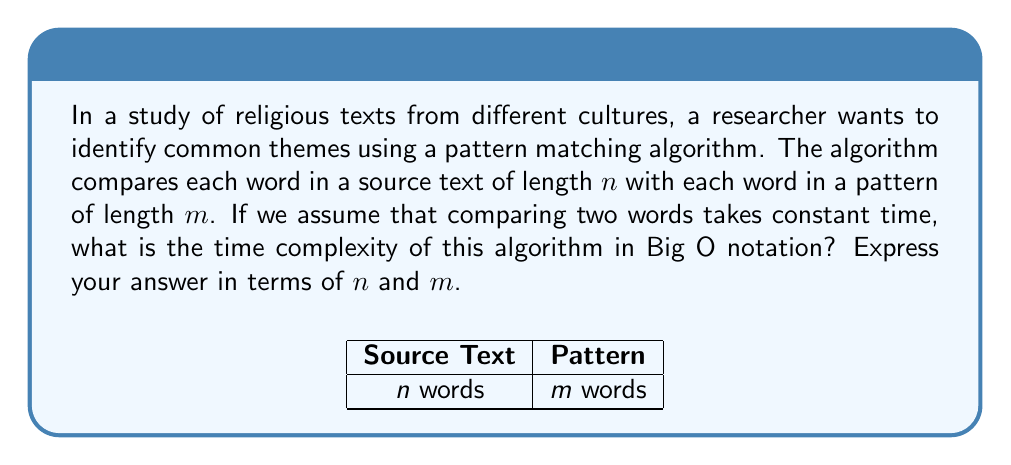Provide a solution to this math problem. Let's approach this step-by-step:

1) First, we need to understand what the algorithm does:
   - It compares each word in the source text (length $n$) with each word in the pattern (length $m$).

2) This forms a nested loop structure:
   - The outer loop iterates through each word in the source text (n times).
   - For each iteration of the outer loop, the inner loop compares with each word in the pattern (m times).

3) The total number of comparisons is therefore:
   $$ n * m $$

4) Each comparison is assumed to take constant time, let's call this time $c$.

5) So, the total time taken by the algorithm is:
   $$ T(n,m) = c * n * m $$

6) In Big O notation, we drop constant factors. Therefore:
   $$ O(n * m) $$

This is the standard time complexity for naive pattern matching algorithms, such as the brute-force string matching algorithm.
Answer: $O(nm)$ 